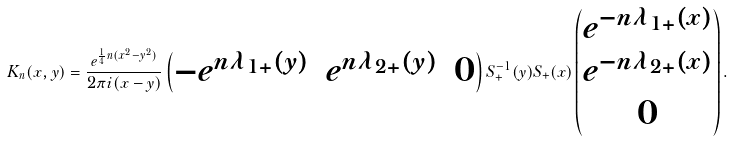<formula> <loc_0><loc_0><loc_500><loc_500>K _ { n } ( x , y ) = \frac { e ^ { \frac { 1 } { 4 } n ( x ^ { 2 } - y ^ { 2 } ) } } { 2 \pi i ( x - y ) } \begin{pmatrix} - e ^ { n \lambda _ { 1 + } ( y ) } & e ^ { n \lambda _ { 2 + } ( y ) } & 0 \end{pmatrix} S _ { + } ^ { - 1 } ( y ) S _ { + } ( x ) \begin{pmatrix} e ^ { - n \lambda _ { 1 + } ( x ) } \\ e ^ { - n \lambda _ { 2 + } ( x ) } \\ 0 \end{pmatrix} .</formula> 